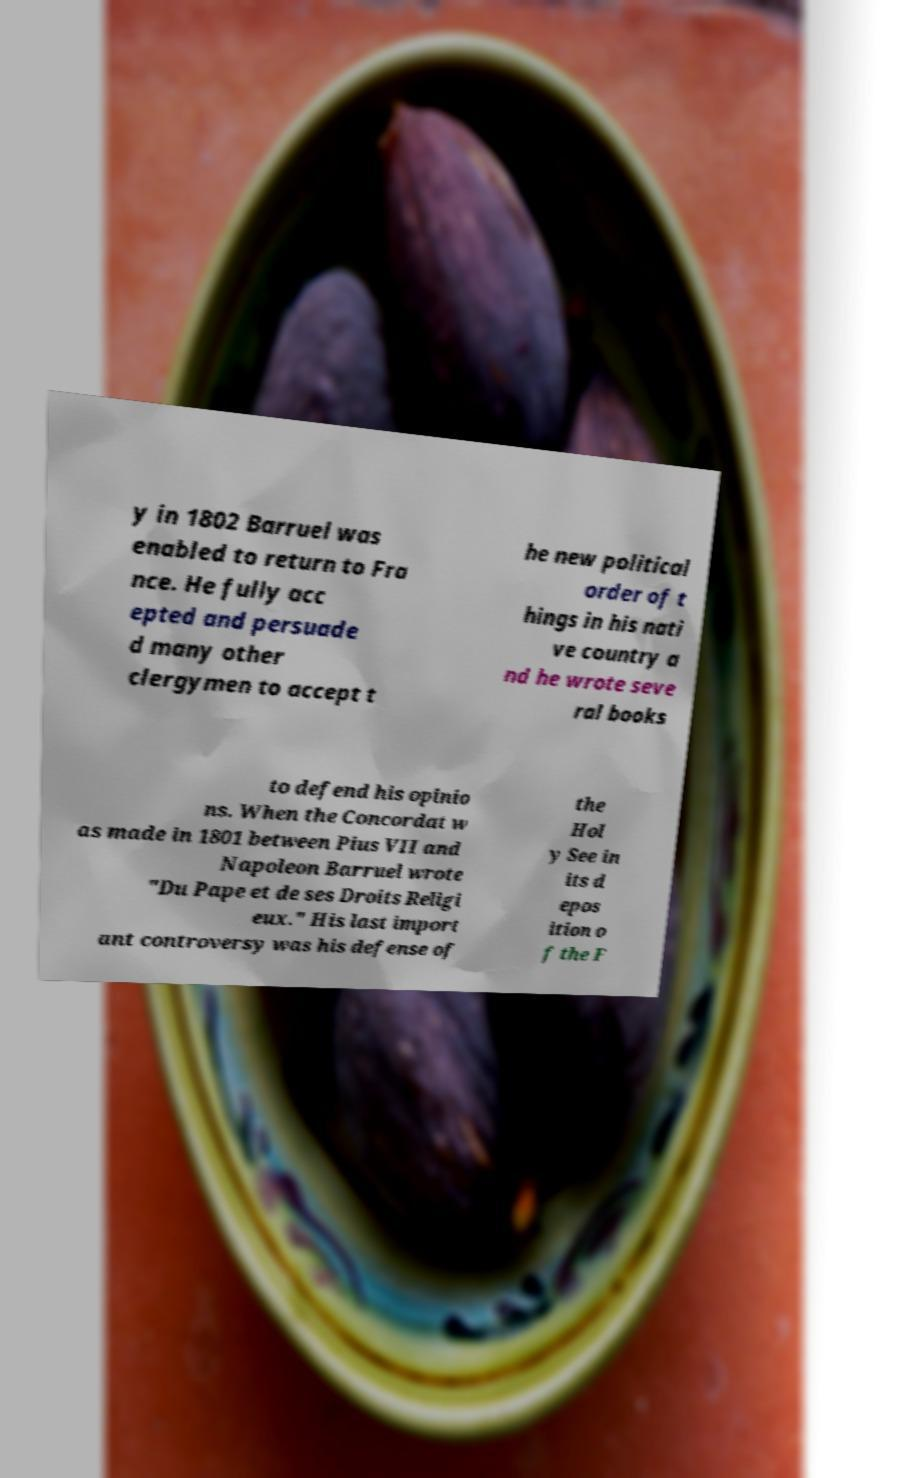Please identify and transcribe the text found in this image. y in 1802 Barruel was enabled to return to Fra nce. He fully acc epted and persuade d many other clergymen to accept t he new political order of t hings in his nati ve country a nd he wrote seve ral books to defend his opinio ns. When the Concordat w as made in 1801 between Pius VII and Napoleon Barruel wrote "Du Pape et de ses Droits Religi eux." His last import ant controversy was his defense of the Hol y See in its d epos ition o f the F 